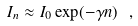Convert formula to latex. <formula><loc_0><loc_0><loc_500><loc_500>I _ { n } \approx I _ { 0 } \exp ( - \gamma n ) \ ,</formula> 